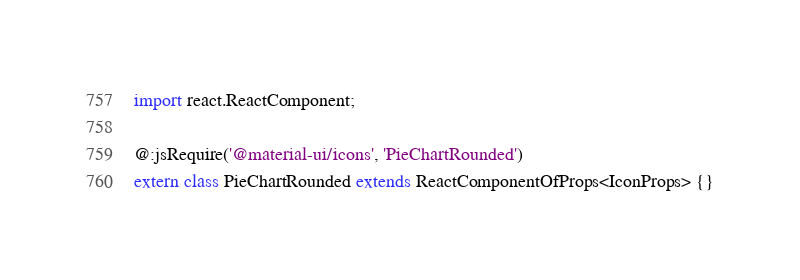Convert code to text. <code><loc_0><loc_0><loc_500><loc_500><_Haxe_>import react.ReactComponent;

@:jsRequire('@material-ui/icons', 'PieChartRounded')
extern class PieChartRounded extends ReactComponentOfProps<IconProps> {}
</code> 